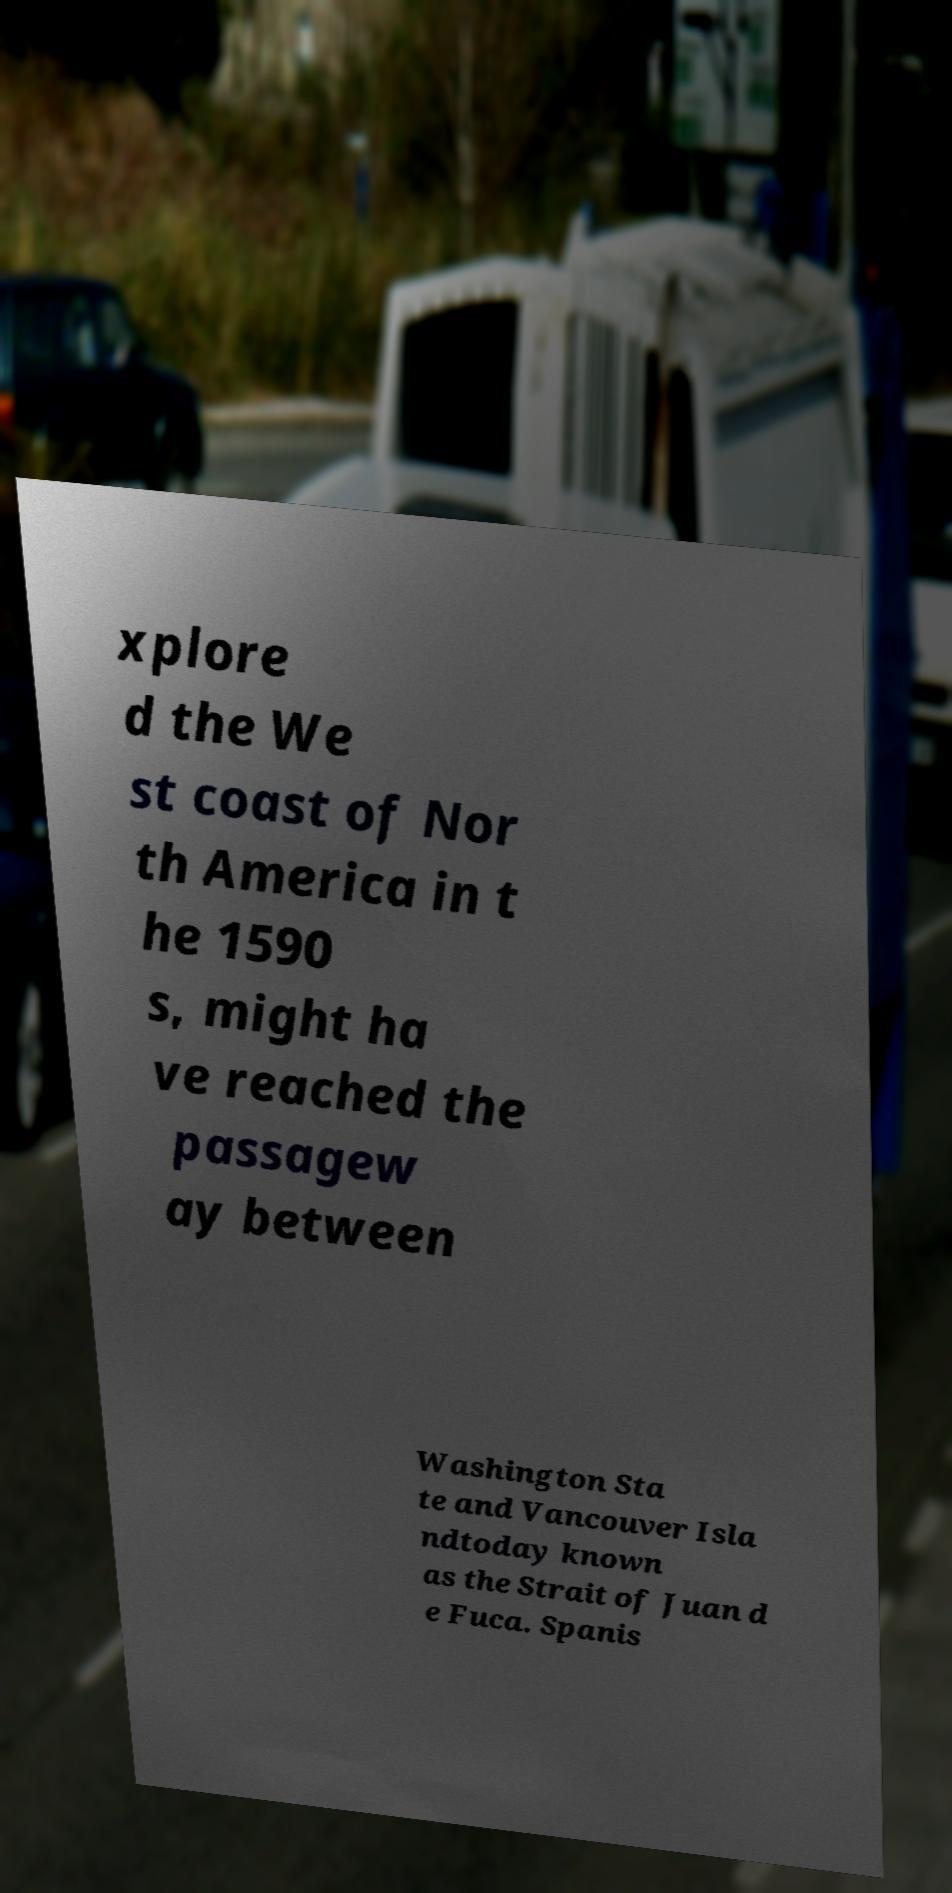Can you read and provide the text displayed in the image?This photo seems to have some interesting text. Can you extract and type it out for me? xplore d the We st coast of Nor th America in t he 1590 s, might ha ve reached the passagew ay between Washington Sta te and Vancouver Isla ndtoday known as the Strait of Juan d e Fuca. Spanis 